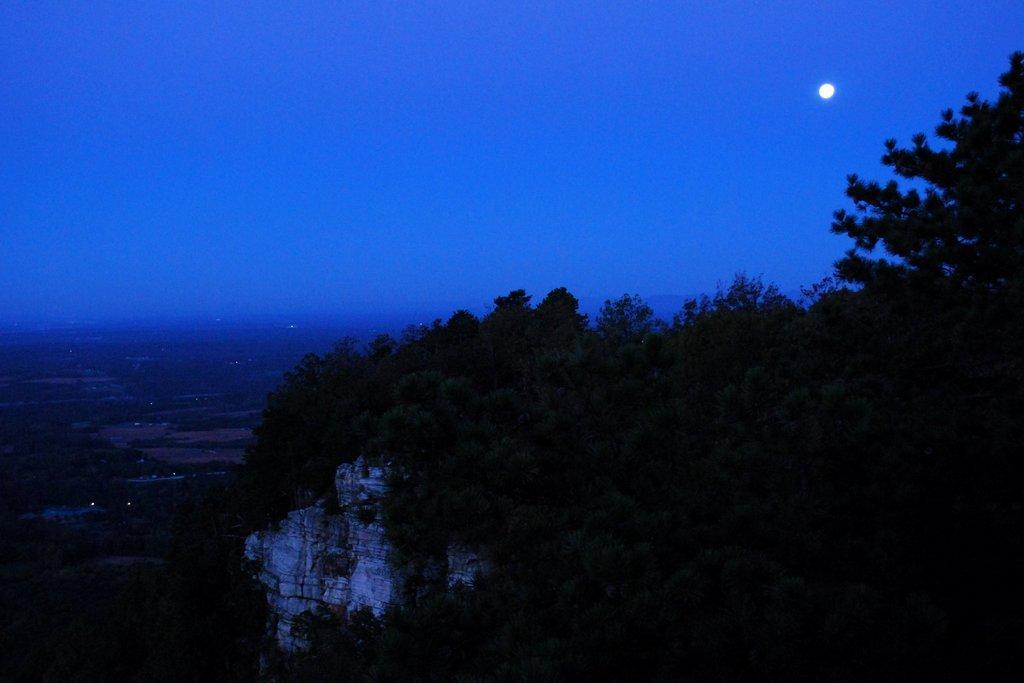Please provide a concise description of this image. In this image there is the sky truncated towards the top of the image, there is the moon in the sky, there are trees truncated towards the right of the image, there are trees truncated towards the bottom of the image, there is a wall, there are trees truncated towards the left of the image, there are lights. 